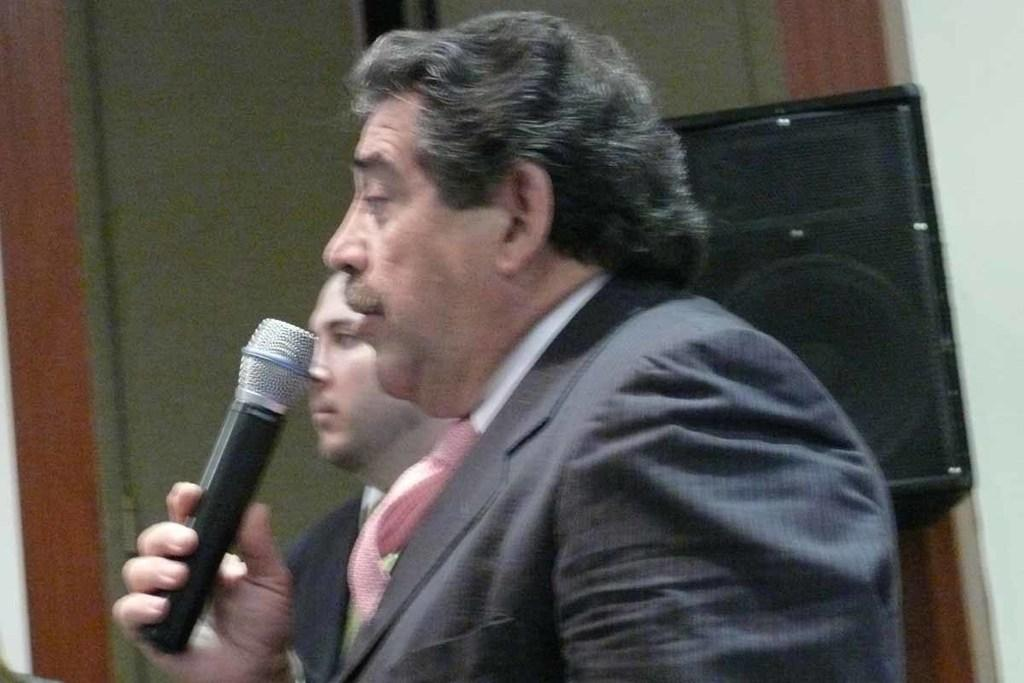What is the man in the image holding? The man is holding a microphone in the image. What is the man with the microphone doing? The man is speaking. Can you describe the other person in the image? There is another man beside the speaking man. What can be seen on the right side of the image? There is a speaker on the right side of the image. What is visible in the background of the image? There is a door in the background of the image. What type of engine is visible in the image? There is no engine present in the image. What experience does the speaking man have in the field of public speaking? The image does not provide any information about the speaking man's experience in public speaking. 